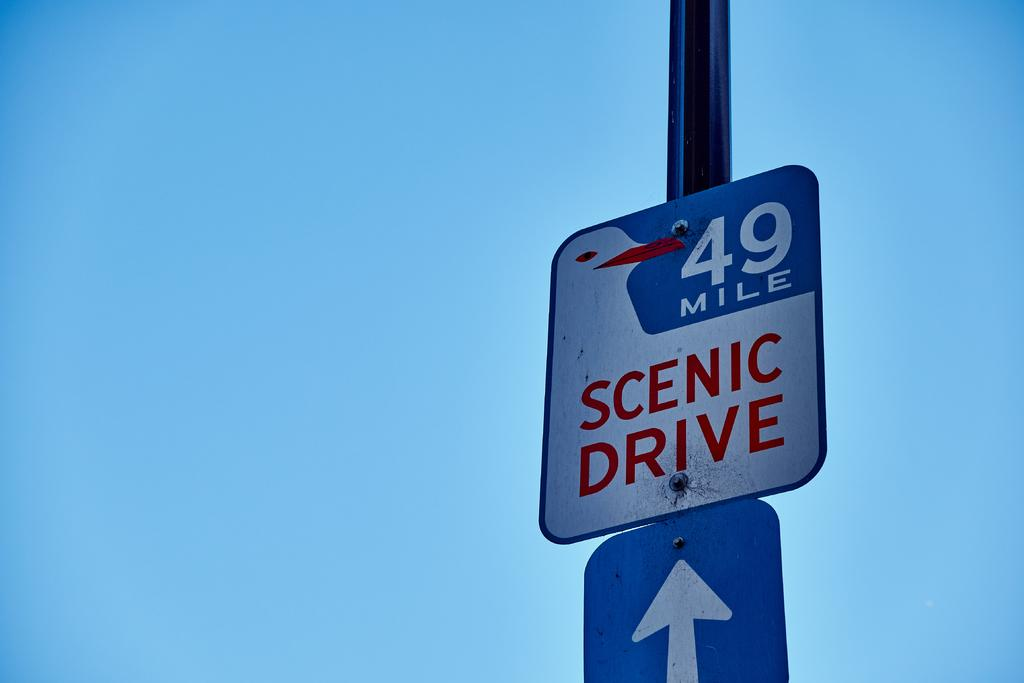<image>
Render a clear and concise summary of the photo. a sign that has 49 mile written on it 